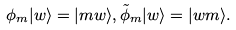<formula> <loc_0><loc_0><loc_500><loc_500>\phi _ { m } | w \rangle = | m w \rangle , \tilde { \phi } _ { m } | w \rangle = | w m \rangle .</formula> 